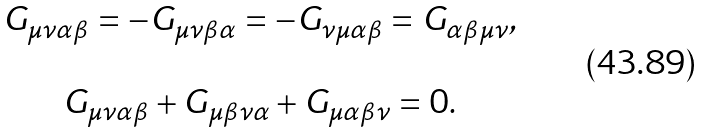<formula> <loc_0><loc_0><loc_500><loc_500>\begin{array} { c } G _ { \mu \nu \alpha \beta } = - G _ { \mu \nu \beta \alpha } = - G _ { \nu \mu \alpha \beta } = G _ { \alpha \beta \mu \nu } , \\ \\ G _ { \mu \nu \alpha \beta } + G _ { \mu \beta \nu \alpha } + G _ { \mu \alpha \beta \nu } = 0 . \end{array}</formula> 